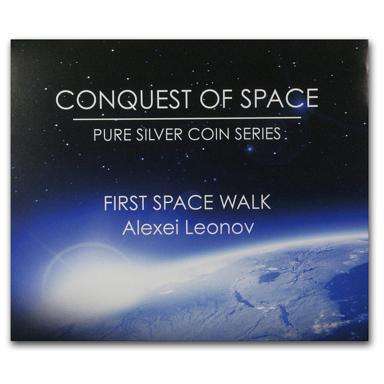What is the main theme of the poster in the image?
 The main theme of the poster is the "Conquest of Space" pure silver coin series, featuring the first spacewalk by Alexei Leonov. Who is Alexei Leonov? Alexei Leonov was a Soviet/Russian cosmonaut, who became the first person to conduct a spacewalk on 18th March 1965, during the Voskhod 2 mission. He was an important figure in the history of space exploration and significantly contributed to advancing human exploration of outer space. 